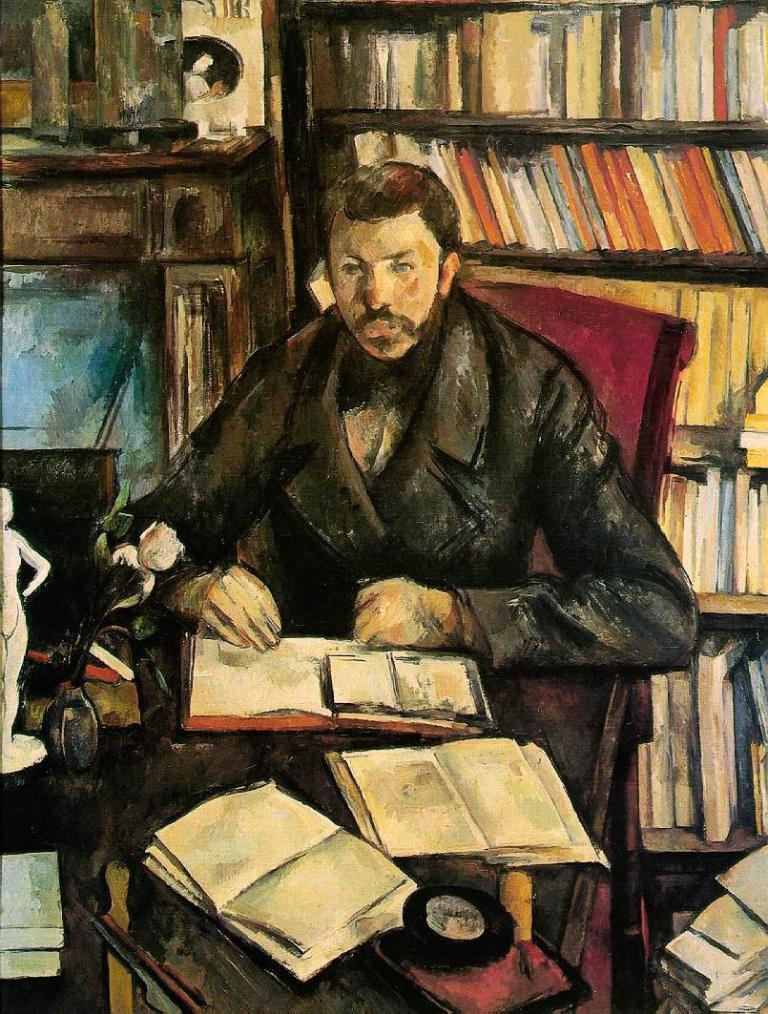Describe this image in one or two sentences. In this image we can see the painting. Here we can see a man sitting on a chair. Here we can see the books and a flower vase on the table. In the background, we can see the books on a wooden shelf. 